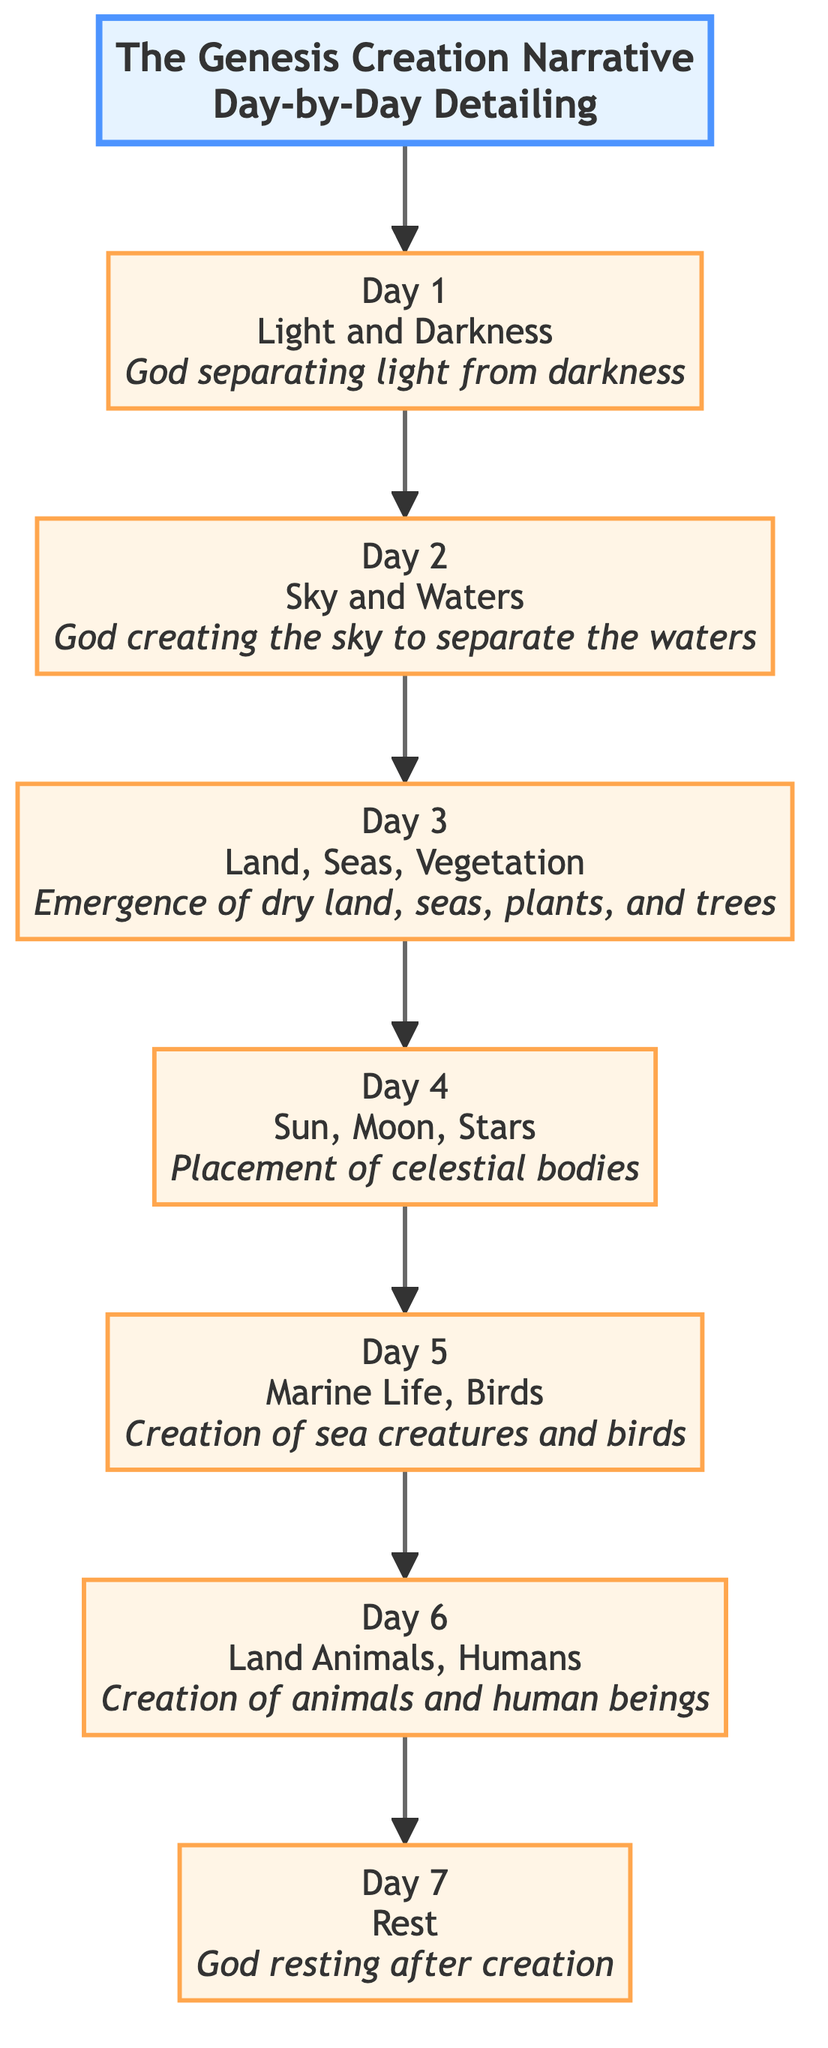What does Day 1 describe? Day 1 is labeled as "Light and Darkness" and states "God separating light from darkness." Thus, it details the creation of light and the distinction from darkness.
Answer: Light and Darkness How many days are dedicated to creation activities in the diagram? The diagram outlines seven distinct days, each representing different creation activities according to the Genesis narrative, from Day 1 to Day 7.
Answer: Seven Which day includes the creation of celestial bodies? Day 4 is specifically about the creation of celestial bodies, stating "Placement of celestial bodies." This differentiates it from other days focused on different creations.
Answer: Day 4 What is created on Day 3? Day 3 describes "Land, Seas, Vegetation" and mentions the emergence of dry land, seas, plants, and trees, indicating a focus on both terrestrial and aqueous environments.
Answer: Land, Seas, Vegetation On which day did God rest? The description states that God rested on Day 7, indicating a completion of the creation process after six days of activity.
Answer: Day 7 What connects Day 5 to Day 6 in the diagram? The flow from Day 5, which involves the creation of marine life and birds, directly leads to Day 6, where land animals and humans are created, showing a progression in the types of creatures made.
Answer: Day 5 to Day 6 Which day is associated with God creating land animals and humans? Day 6 is where it mentions the creation of land animals and humans, adding significance to the day's role in the overall creation narrative.
Answer: Day 6 What is the purpose of Day 2? On Day 2, the focus is on the "Sky and Waters," as the diagram highlights God creating the sky to separate the waters, illustrating the establishment of the Earth's atmosphere.
Answer: Sky and Waters How does the diagram depict the sequence of creation? The diagram shows a linear flow from Day 1 to Day 7, demonstrating a chronological sequence in which each day's creation builds upon the previous day.
Answer: Linear flow from Day 1 to Day 7 